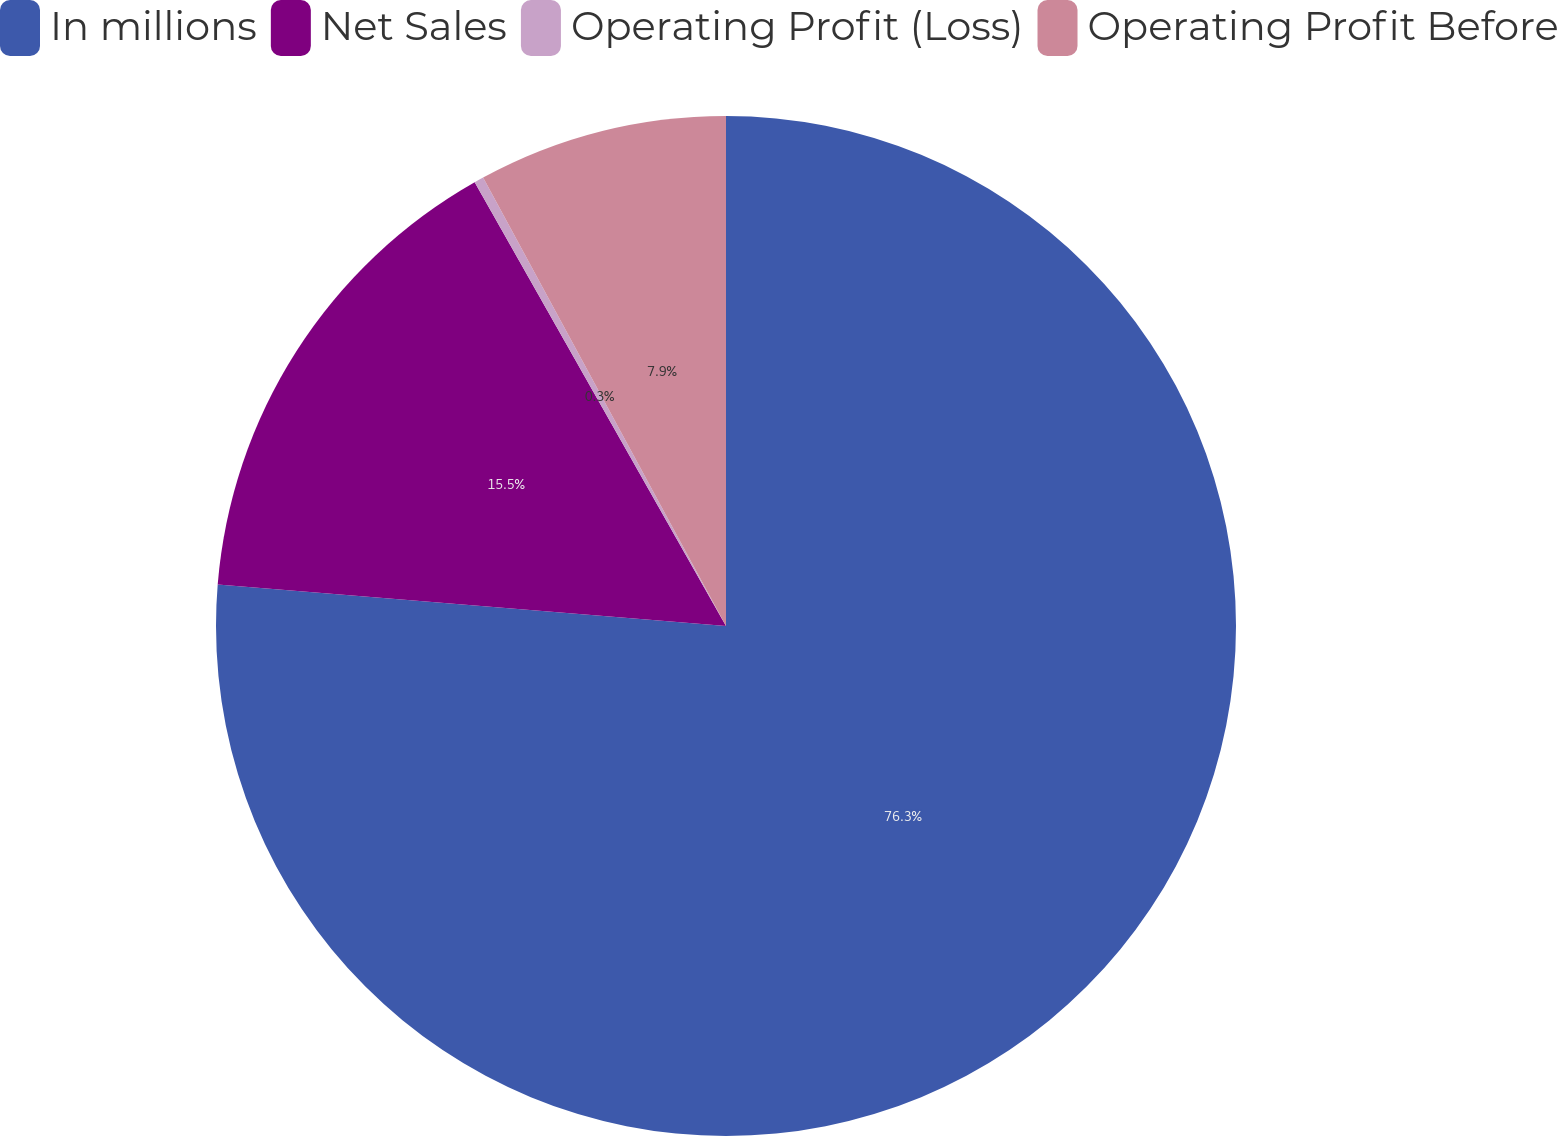<chart> <loc_0><loc_0><loc_500><loc_500><pie_chart><fcel>In millions<fcel>Net Sales<fcel>Operating Profit (Loss)<fcel>Operating Profit Before<nl><fcel>76.29%<fcel>15.5%<fcel>0.3%<fcel>7.9%<nl></chart> 